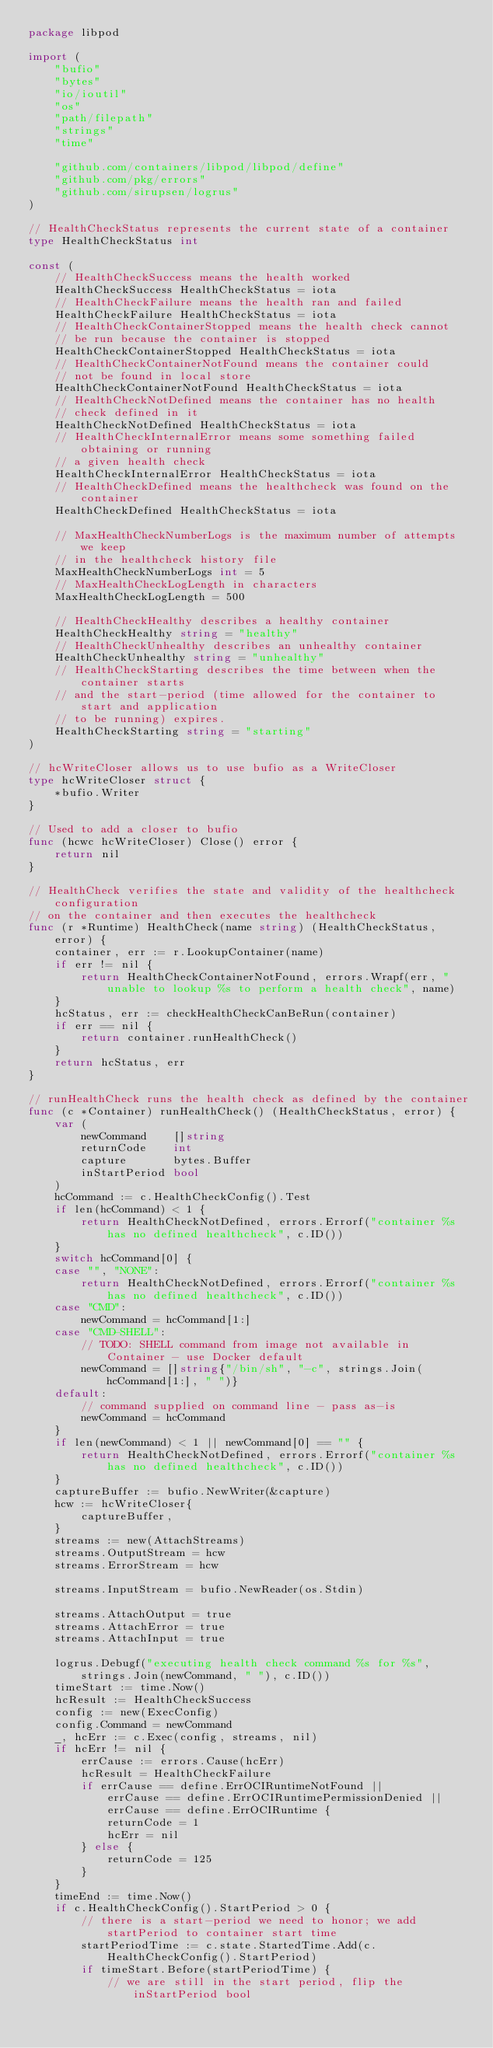<code> <loc_0><loc_0><loc_500><loc_500><_Go_>package libpod

import (
	"bufio"
	"bytes"
	"io/ioutil"
	"os"
	"path/filepath"
	"strings"
	"time"

	"github.com/containers/libpod/libpod/define"
	"github.com/pkg/errors"
	"github.com/sirupsen/logrus"
)

// HealthCheckStatus represents the current state of a container
type HealthCheckStatus int

const (
	// HealthCheckSuccess means the health worked
	HealthCheckSuccess HealthCheckStatus = iota
	// HealthCheckFailure means the health ran and failed
	HealthCheckFailure HealthCheckStatus = iota
	// HealthCheckContainerStopped means the health check cannot
	// be run because the container is stopped
	HealthCheckContainerStopped HealthCheckStatus = iota
	// HealthCheckContainerNotFound means the container could
	// not be found in local store
	HealthCheckContainerNotFound HealthCheckStatus = iota
	// HealthCheckNotDefined means the container has no health
	// check defined in it
	HealthCheckNotDefined HealthCheckStatus = iota
	// HealthCheckInternalError means some something failed obtaining or running
	// a given health check
	HealthCheckInternalError HealthCheckStatus = iota
	// HealthCheckDefined means the healthcheck was found on the container
	HealthCheckDefined HealthCheckStatus = iota

	// MaxHealthCheckNumberLogs is the maximum number of attempts we keep
	// in the healthcheck history file
	MaxHealthCheckNumberLogs int = 5
	// MaxHealthCheckLogLength in characters
	MaxHealthCheckLogLength = 500

	// HealthCheckHealthy describes a healthy container
	HealthCheckHealthy string = "healthy"
	// HealthCheckUnhealthy describes an unhealthy container
	HealthCheckUnhealthy string = "unhealthy"
	// HealthCheckStarting describes the time between when the container starts
	// and the start-period (time allowed for the container to start and application
	// to be running) expires.
	HealthCheckStarting string = "starting"
)

// hcWriteCloser allows us to use bufio as a WriteCloser
type hcWriteCloser struct {
	*bufio.Writer
}

// Used to add a closer to bufio
func (hcwc hcWriteCloser) Close() error {
	return nil
}

// HealthCheck verifies the state and validity of the healthcheck configuration
// on the container and then executes the healthcheck
func (r *Runtime) HealthCheck(name string) (HealthCheckStatus, error) {
	container, err := r.LookupContainer(name)
	if err != nil {
		return HealthCheckContainerNotFound, errors.Wrapf(err, "unable to lookup %s to perform a health check", name)
	}
	hcStatus, err := checkHealthCheckCanBeRun(container)
	if err == nil {
		return container.runHealthCheck()
	}
	return hcStatus, err
}

// runHealthCheck runs the health check as defined by the container
func (c *Container) runHealthCheck() (HealthCheckStatus, error) {
	var (
		newCommand    []string
		returnCode    int
		capture       bytes.Buffer
		inStartPeriod bool
	)
	hcCommand := c.HealthCheckConfig().Test
	if len(hcCommand) < 1 {
		return HealthCheckNotDefined, errors.Errorf("container %s has no defined healthcheck", c.ID())
	}
	switch hcCommand[0] {
	case "", "NONE":
		return HealthCheckNotDefined, errors.Errorf("container %s has no defined healthcheck", c.ID())
	case "CMD":
		newCommand = hcCommand[1:]
	case "CMD-SHELL":
		// TODO: SHELL command from image not available in Container - use Docker default
		newCommand = []string{"/bin/sh", "-c", strings.Join(hcCommand[1:], " ")}
	default:
		// command supplied on command line - pass as-is
		newCommand = hcCommand
	}
	if len(newCommand) < 1 || newCommand[0] == "" {
		return HealthCheckNotDefined, errors.Errorf("container %s has no defined healthcheck", c.ID())
	}
	captureBuffer := bufio.NewWriter(&capture)
	hcw := hcWriteCloser{
		captureBuffer,
	}
	streams := new(AttachStreams)
	streams.OutputStream = hcw
	streams.ErrorStream = hcw

	streams.InputStream = bufio.NewReader(os.Stdin)

	streams.AttachOutput = true
	streams.AttachError = true
	streams.AttachInput = true

	logrus.Debugf("executing health check command %s for %s", strings.Join(newCommand, " "), c.ID())
	timeStart := time.Now()
	hcResult := HealthCheckSuccess
	config := new(ExecConfig)
	config.Command = newCommand
	_, hcErr := c.Exec(config, streams, nil)
	if hcErr != nil {
		errCause := errors.Cause(hcErr)
		hcResult = HealthCheckFailure
		if errCause == define.ErrOCIRuntimeNotFound ||
			errCause == define.ErrOCIRuntimePermissionDenied ||
			errCause == define.ErrOCIRuntime {
			returnCode = 1
			hcErr = nil
		} else {
			returnCode = 125
		}
	}
	timeEnd := time.Now()
	if c.HealthCheckConfig().StartPeriod > 0 {
		// there is a start-period we need to honor; we add startPeriod to container start time
		startPeriodTime := c.state.StartedTime.Add(c.HealthCheckConfig().StartPeriod)
		if timeStart.Before(startPeriodTime) {
			// we are still in the start period, flip the inStartPeriod bool</code> 